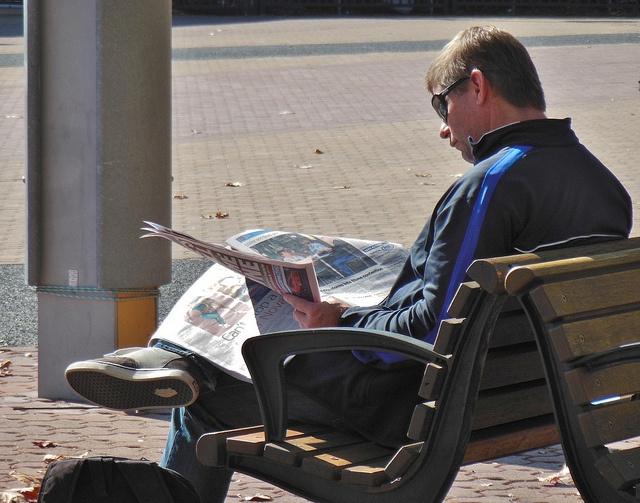Describe the objects in this image and their specific colors. I can see people in black, gray, darkgray, and white tones, bench in black, gray, and darkgray tones, bench in black and gray tones, and backpack in black, gray, maroon, and darkgray tones in this image. 